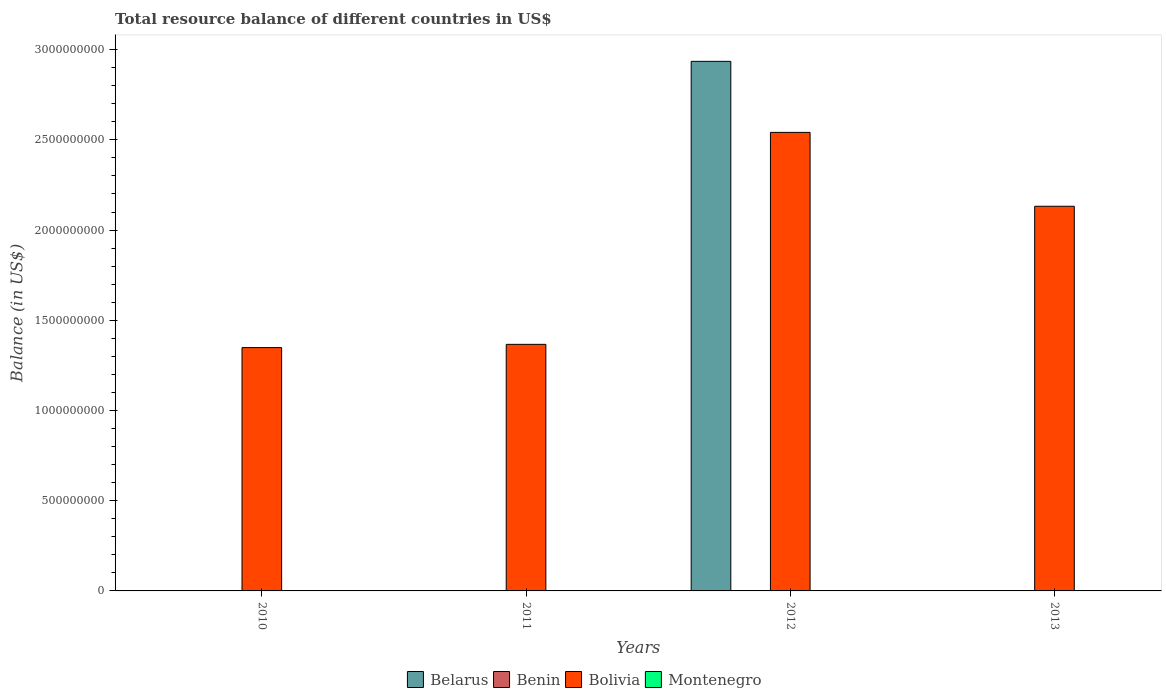Are the number of bars per tick equal to the number of legend labels?
Keep it short and to the point. No. Are the number of bars on each tick of the X-axis equal?
Your answer should be very brief. No. How many bars are there on the 1st tick from the right?
Your answer should be very brief. 1. What is the label of the 3rd group of bars from the left?
Your answer should be compact. 2012. In how many cases, is the number of bars for a given year not equal to the number of legend labels?
Offer a very short reply. 4. What is the total resource balance in Benin in 2010?
Provide a succinct answer. 0. Across all years, what is the maximum total resource balance in Belarus?
Offer a terse response. 2.94e+09. Across all years, what is the minimum total resource balance in Benin?
Keep it short and to the point. 0. In which year was the total resource balance in Bolivia maximum?
Provide a short and direct response. 2012. What is the total total resource balance in Montenegro in the graph?
Offer a very short reply. 0. What is the difference between the total resource balance in Bolivia in 2010 and that in 2012?
Your response must be concise. -1.19e+09. What is the difference between the total resource balance in Benin in 2010 and the total resource balance in Montenegro in 2012?
Keep it short and to the point. 0. What is the ratio of the total resource balance in Bolivia in 2011 to that in 2013?
Your response must be concise. 0.64. What is the difference between the highest and the second highest total resource balance in Bolivia?
Your answer should be compact. 4.09e+08. What is the difference between the highest and the lowest total resource balance in Belarus?
Your response must be concise. 2.94e+09. Is it the case that in every year, the sum of the total resource balance in Benin and total resource balance in Montenegro is greater than the sum of total resource balance in Bolivia and total resource balance in Belarus?
Your answer should be compact. No. How many years are there in the graph?
Offer a terse response. 4. Does the graph contain any zero values?
Give a very brief answer. Yes. Where does the legend appear in the graph?
Your answer should be very brief. Bottom center. How many legend labels are there?
Your answer should be very brief. 4. How are the legend labels stacked?
Keep it short and to the point. Horizontal. What is the title of the graph?
Keep it short and to the point. Total resource balance of different countries in US$. Does "Seychelles" appear as one of the legend labels in the graph?
Your response must be concise. No. What is the label or title of the X-axis?
Provide a short and direct response. Years. What is the label or title of the Y-axis?
Your answer should be compact. Balance (in US$). What is the Balance (in US$) in Belarus in 2010?
Give a very brief answer. 0. What is the Balance (in US$) in Bolivia in 2010?
Offer a very short reply. 1.35e+09. What is the Balance (in US$) in Belarus in 2011?
Provide a short and direct response. 0. What is the Balance (in US$) of Benin in 2011?
Provide a short and direct response. 0. What is the Balance (in US$) in Bolivia in 2011?
Your answer should be compact. 1.37e+09. What is the Balance (in US$) in Montenegro in 2011?
Keep it short and to the point. 0. What is the Balance (in US$) in Belarus in 2012?
Offer a very short reply. 2.94e+09. What is the Balance (in US$) of Benin in 2012?
Your answer should be very brief. 0. What is the Balance (in US$) in Bolivia in 2012?
Ensure brevity in your answer.  2.54e+09. What is the Balance (in US$) of Montenegro in 2012?
Provide a succinct answer. 0. What is the Balance (in US$) of Belarus in 2013?
Your answer should be compact. 0. What is the Balance (in US$) of Benin in 2013?
Make the answer very short. 0. What is the Balance (in US$) in Bolivia in 2013?
Your answer should be very brief. 2.13e+09. Across all years, what is the maximum Balance (in US$) of Belarus?
Provide a succinct answer. 2.94e+09. Across all years, what is the maximum Balance (in US$) of Bolivia?
Provide a succinct answer. 2.54e+09. Across all years, what is the minimum Balance (in US$) of Bolivia?
Ensure brevity in your answer.  1.35e+09. What is the total Balance (in US$) in Belarus in the graph?
Give a very brief answer. 2.94e+09. What is the total Balance (in US$) in Bolivia in the graph?
Offer a very short reply. 7.39e+09. What is the difference between the Balance (in US$) of Bolivia in 2010 and that in 2011?
Your answer should be very brief. -1.80e+07. What is the difference between the Balance (in US$) of Bolivia in 2010 and that in 2012?
Make the answer very short. -1.19e+09. What is the difference between the Balance (in US$) of Bolivia in 2010 and that in 2013?
Give a very brief answer. -7.83e+08. What is the difference between the Balance (in US$) in Bolivia in 2011 and that in 2012?
Give a very brief answer. -1.17e+09. What is the difference between the Balance (in US$) of Bolivia in 2011 and that in 2013?
Your answer should be very brief. -7.65e+08. What is the difference between the Balance (in US$) of Bolivia in 2012 and that in 2013?
Your response must be concise. 4.09e+08. What is the difference between the Balance (in US$) in Belarus in 2012 and the Balance (in US$) in Bolivia in 2013?
Your answer should be compact. 8.03e+08. What is the average Balance (in US$) of Belarus per year?
Provide a short and direct response. 7.34e+08. What is the average Balance (in US$) of Bolivia per year?
Offer a very short reply. 1.85e+09. What is the average Balance (in US$) of Montenegro per year?
Give a very brief answer. 0. In the year 2012, what is the difference between the Balance (in US$) of Belarus and Balance (in US$) of Bolivia?
Provide a short and direct response. 3.94e+08. What is the ratio of the Balance (in US$) in Bolivia in 2010 to that in 2012?
Your answer should be very brief. 0.53. What is the ratio of the Balance (in US$) of Bolivia in 2010 to that in 2013?
Your response must be concise. 0.63. What is the ratio of the Balance (in US$) of Bolivia in 2011 to that in 2012?
Give a very brief answer. 0.54. What is the ratio of the Balance (in US$) of Bolivia in 2011 to that in 2013?
Your answer should be compact. 0.64. What is the ratio of the Balance (in US$) in Bolivia in 2012 to that in 2013?
Give a very brief answer. 1.19. What is the difference between the highest and the second highest Balance (in US$) of Bolivia?
Offer a terse response. 4.09e+08. What is the difference between the highest and the lowest Balance (in US$) of Belarus?
Offer a terse response. 2.94e+09. What is the difference between the highest and the lowest Balance (in US$) in Bolivia?
Offer a very short reply. 1.19e+09. 